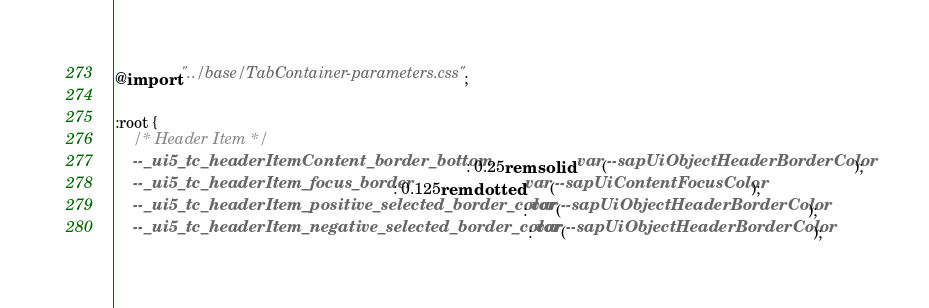<code> <loc_0><loc_0><loc_500><loc_500><_CSS_>@import "../base/TabContainer-parameters.css";

:root {
	/* Header Item */
	--_ui5_tc_headerItemContent_border_bottom: 0.25rem solid var(--sapUiObjectHeaderBorderColor);
	--_ui5_tc_headerItem_focus_border: 0.125rem dotted var(--sapUiContentFocusColor);
	--_ui5_tc_headerItem_positive_selected_border_color: var(--sapUiObjectHeaderBorderColor);
	--_ui5_tc_headerItem_negative_selected_border_color: var(--sapUiObjectHeaderBorderColor);</code> 